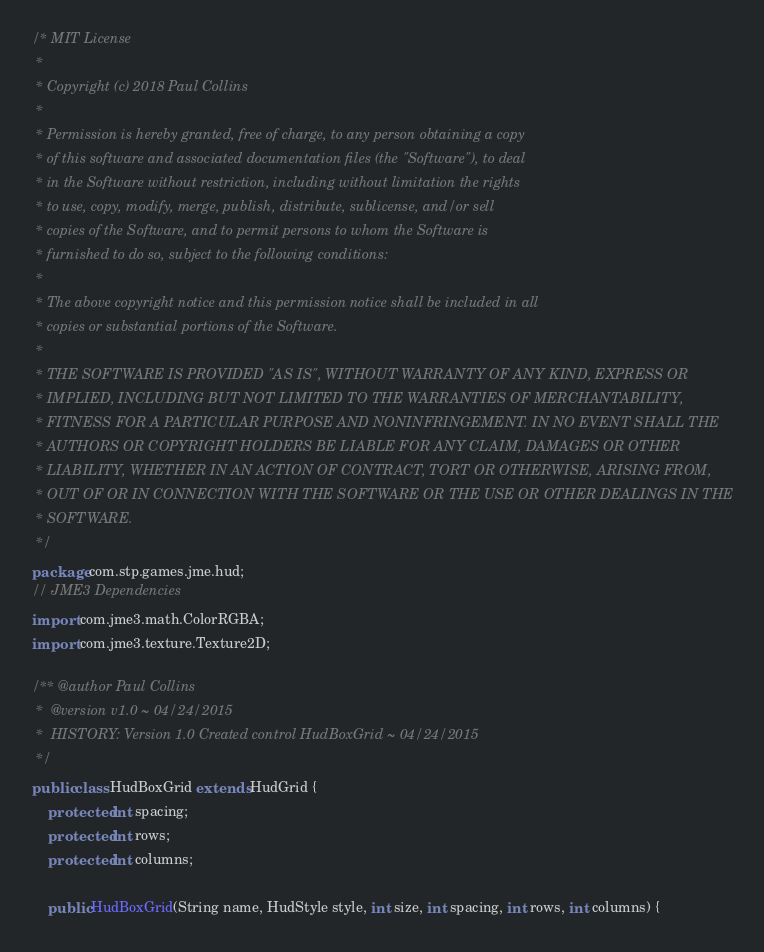Convert code to text. <code><loc_0><loc_0><loc_500><loc_500><_Java_>/* MIT License
 *
 * Copyright (c) 2018 Paul Collins
 *
 * Permission is hereby granted, free of charge, to any person obtaining a copy
 * of this software and associated documentation files (the "Software"), to deal
 * in the Software without restriction, including without limitation the rights
 * to use, copy, modify, merge, publish, distribute, sublicense, and/or sell
 * copies of the Software, and to permit persons to whom the Software is
 * furnished to do so, subject to the following conditions:
 *
 * The above copyright notice and this permission notice shall be included in all
 * copies or substantial portions of the Software.
 *
 * THE SOFTWARE IS PROVIDED "AS IS", WITHOUT WARRANTY OF ANY KIND, EXPRESS OR
 * IMPLIED, INCLUDING BUT NOT LIMITED TO THE WARRANTIES OF MERCHANTABILITY,
 * FITNESS FOR A PARTICULAR PURPOSE AND NONINFRINGEMENT. IN NO EVENT SHALL THE
 * AUTHORS OR COPYRIGHT HOLDERS BE LIABLE FOR ANY CLAIM, DAMAGES OR OTHER
 * LIABILITY, WHETHER IN AN ACTION OF CONTRACT, TORT OR OTHERWISE, ARISING FROM,
 * OUT OF OR IN CONNECTION WITH THE SOFTWARE OR THE USE OR OTHER DEALINGS IN THE
 * SOFTWARE.
 */
package com.stp.games.jme.hud;
// JME3 Dependencies
import com.jme3.math.ColorRGBA;
import com.jme3.texture.Texture2D;

/** @author Paul Collins
 *  @version v1.0 ~ 04/24/2015
 *  HISTORY: Version 1.0 Created control HudBoxGrid ~ 04/24/2015
 */
public class HudBoxGrid extends HudGrid {
	protected int spacing;
	protected int rows;
	protected int columns;

	public HudBoxGrid(String name, HudStyle style, int size, int spacing, int rows, int columns) {</code> 